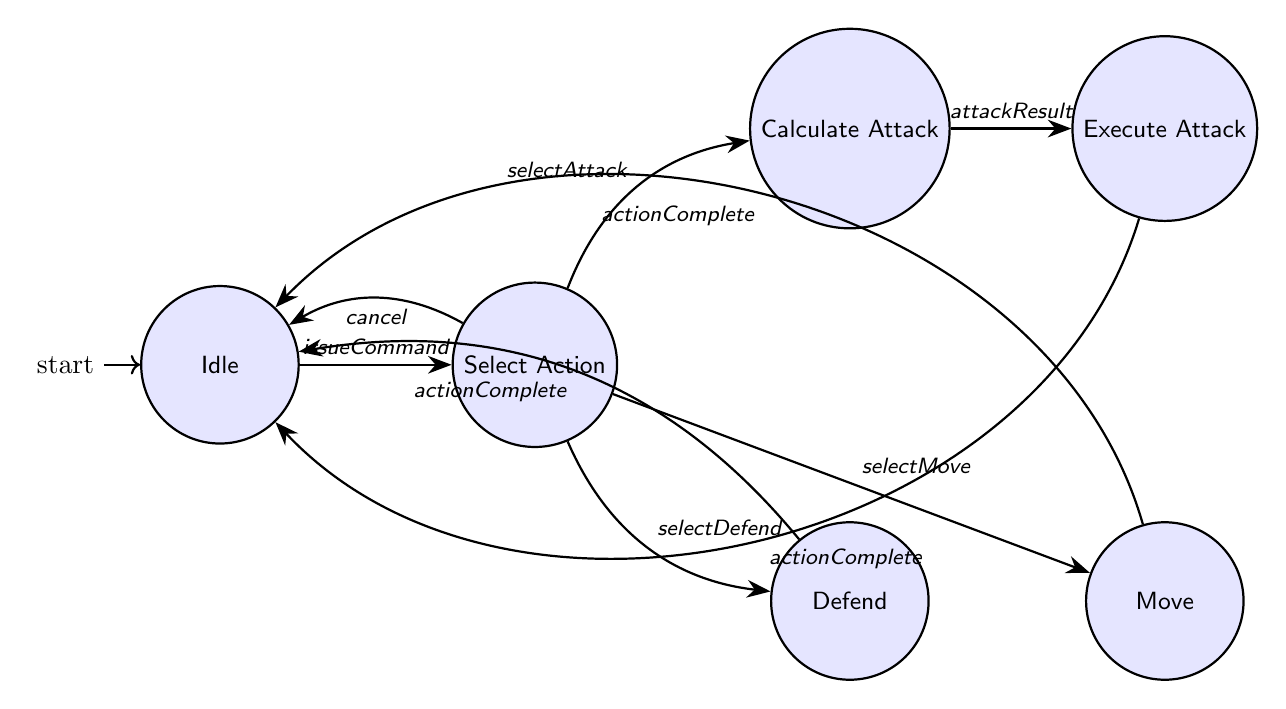What is the initial state in the diagram? The initial state is marked clearly in the diagram with an incoming arrow from nowhere, indicating it is the starting point of the finite state machine. The state 'Idle' receives this initial indication.
Answer: Idle How many states are present in the diagram? By counting the circles representing the states in the diagram, we find there are six distinct states: Idle, Select Action, Calculate Attack, Execute Attack, Defend, and Move.
Answer: Six What action leads from 'Select Action' to 'Calculate Attack'? The transition from 'Select Action' to 'Calculate Attack' occurs when the player selects the action labeled 'selectAttack'. This is indicated by an arrow connecting these two states.
Answer: selectAttack Which state is reached upon completing an attack in 'Calculate Attack'? After the attack result is determined in 'Calculate Attack', the next state is 'Execute Attack' as indicated by the transition marked with 'attackResult'. This follows the logical flow from calculating to executing the attack.
Answer: Execute Attack What happens when the player cancels in the 'Select Action' state? If the player issues a 'cancel' command while in the 'Select Action' state, the transition directs back to the 'Idle' state, which indicates no action will be performed. This is depicted by the arrow leading back to 'Idle'.
Answer: Idle What state follows after 'Defend' action is completed? Upon completing the defend action in the 'Defend' state, the transition leads back to 'Idle' as denoted by the 'actionComplete' trigger, indicating the unit is ready for a new command.
Answer: Idle How does the state machine transition from the 'Move' state? Once the action in the 'Move' state is completed, the transition also goes back to 'Idle' indicated by the 'actionComplete' trigger, allowing the unit to await further instructions.
Answer: Idle What type of strategies does the AI integrate during the 'Calculate Attack'? During the 'Calculate Attack' phase, the AI integrates counter-strategies which are considered while calculating the outcomes of potential attacks. This reflects the tactical depth of the combat mechanism.
Answer: Counter-strategies 